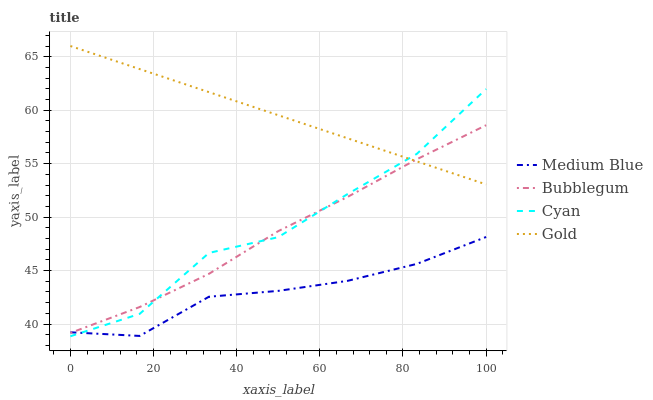Does Medium Blue have the minimum area under the curve?
Answer yes or no. Yes. Does Gold have the maximum area under the curve?
Answer yes or no. Yes. Does Gold have the minimum area under the curve?
Answer yes or no. No. Does Medium Blue have the maximum area under the curve?
Answer yes or no. No. Is Gold the smoothest?
Answer yes or no. Yes. Is Cyan the roughest?
Answer yes or no. Yes. Is Medium Blue the smoothest?
Answer yes or no. No. Is Medium Blue the roughest?
Answer yes or no. No. Does Cyan have the lowest value?
Answer yes or no. Yes. Does Medium Blue have the lowest value?
Answer yes or no. No. Does Gold have the highest value?
Answer yes or no. Yes. Does Medium Blue have the highest value?
Answer yes or no. No. Is Medium Blue less than Gold?
Answer yes or no. Yes. Is Gold greater than Medium Blue?
Answer yes or no. Yes. Does Cyan intersect Gold?
Answer yes or no. Yes. Is Cyan less than Gold?
Answer yes or no. No. Is Cyan greater than Gold?
Answer yes or no. No. Does Medium Blue intersect Gold?
Answer yes or no. No. 